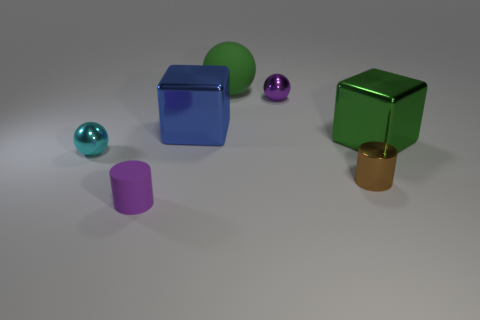Subtract all tiny spheres. How many spheres are left? 1 Subtract all cyan spheres. How many spheres are left? 2 Add 2 purple rubber blocks. How many objects exist? 9 Subtract 1 spheres. How many spheres are left? 2 Subtract all cylinders. How many objects are left? 5 Subtract all brown spheres. Subtract all blue cylinders. How many spheres are left? 3 Subtract 0 brown cubes. How many objects are left? 7 Subtract all shiny cubes. Subtract all large green shiny blocks. How many objects are left? 4 Add 1 small purple objects. How many small purple objects are left? 3 Add 4 tiny purple balls. How many tiny purple balls exist? 5 